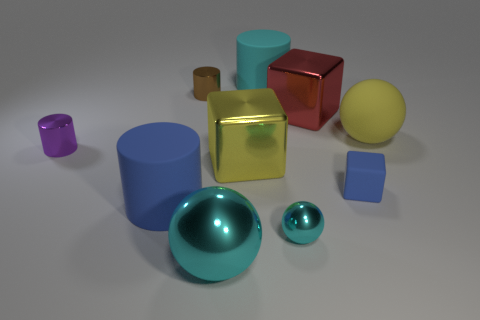What number of blue rubber objects are there?
Provide a short and direct response. 2. There is a large block that is made of the same material as the red object; what is its color?
Provide a short and direct response. Yellow. How many big things are yellow things or blue cylinders?
Provide a short and direct response. 3. There is a small blue cube; what number of large shiny objects are in front of it?
Keep it short and to the point. 1. The matte object that is the same shape as the big yellow metallic thing is what color?
Your answer should be compact. Blue. What number of metallic things are tiny purple objects or balls?
Your answer should be compact. 3. There is a cylinder that is on the left side of the large matte thing that is left of the small brown shiny object; are there any big yellow things behind it?
Offer a very short reply. Yes. The matte block is what color?
Your response must be concise. Blue. Does the large cyan thing in front of the tiny brown cylinder have the same shape as the red thing?
Keep it short and to the point. No. What number of objects are either cyan shiny balls or yellow things right of the small cyan shiny object?
Your response must be concise. 3. 